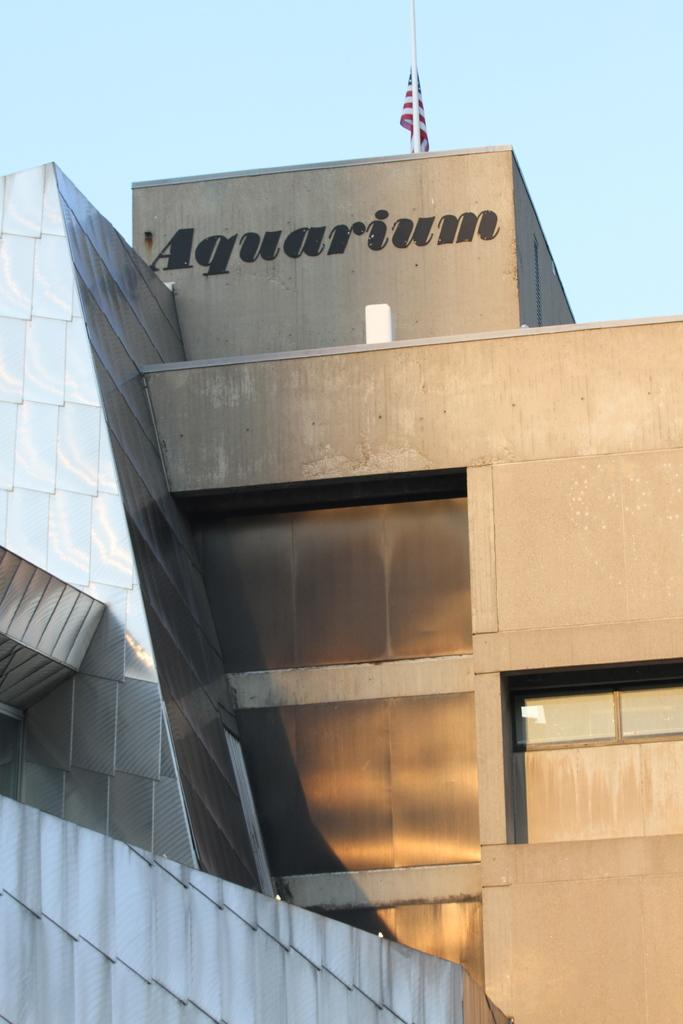What is located on the building in the image? There is a flag on a building in the image. Where is the flag positioned on the building? The flag is in the middle of the image. What can be seen in the background of the image? There is a sky visible in the background of the image. What type of love can be seen in the image? There is no love present in the image; it features a flag on a building and a sky in the background. How many balloons are floating in the sky in the image? There are no balloons visible in the image; it only shows a flag on a building and a sky in the background. 